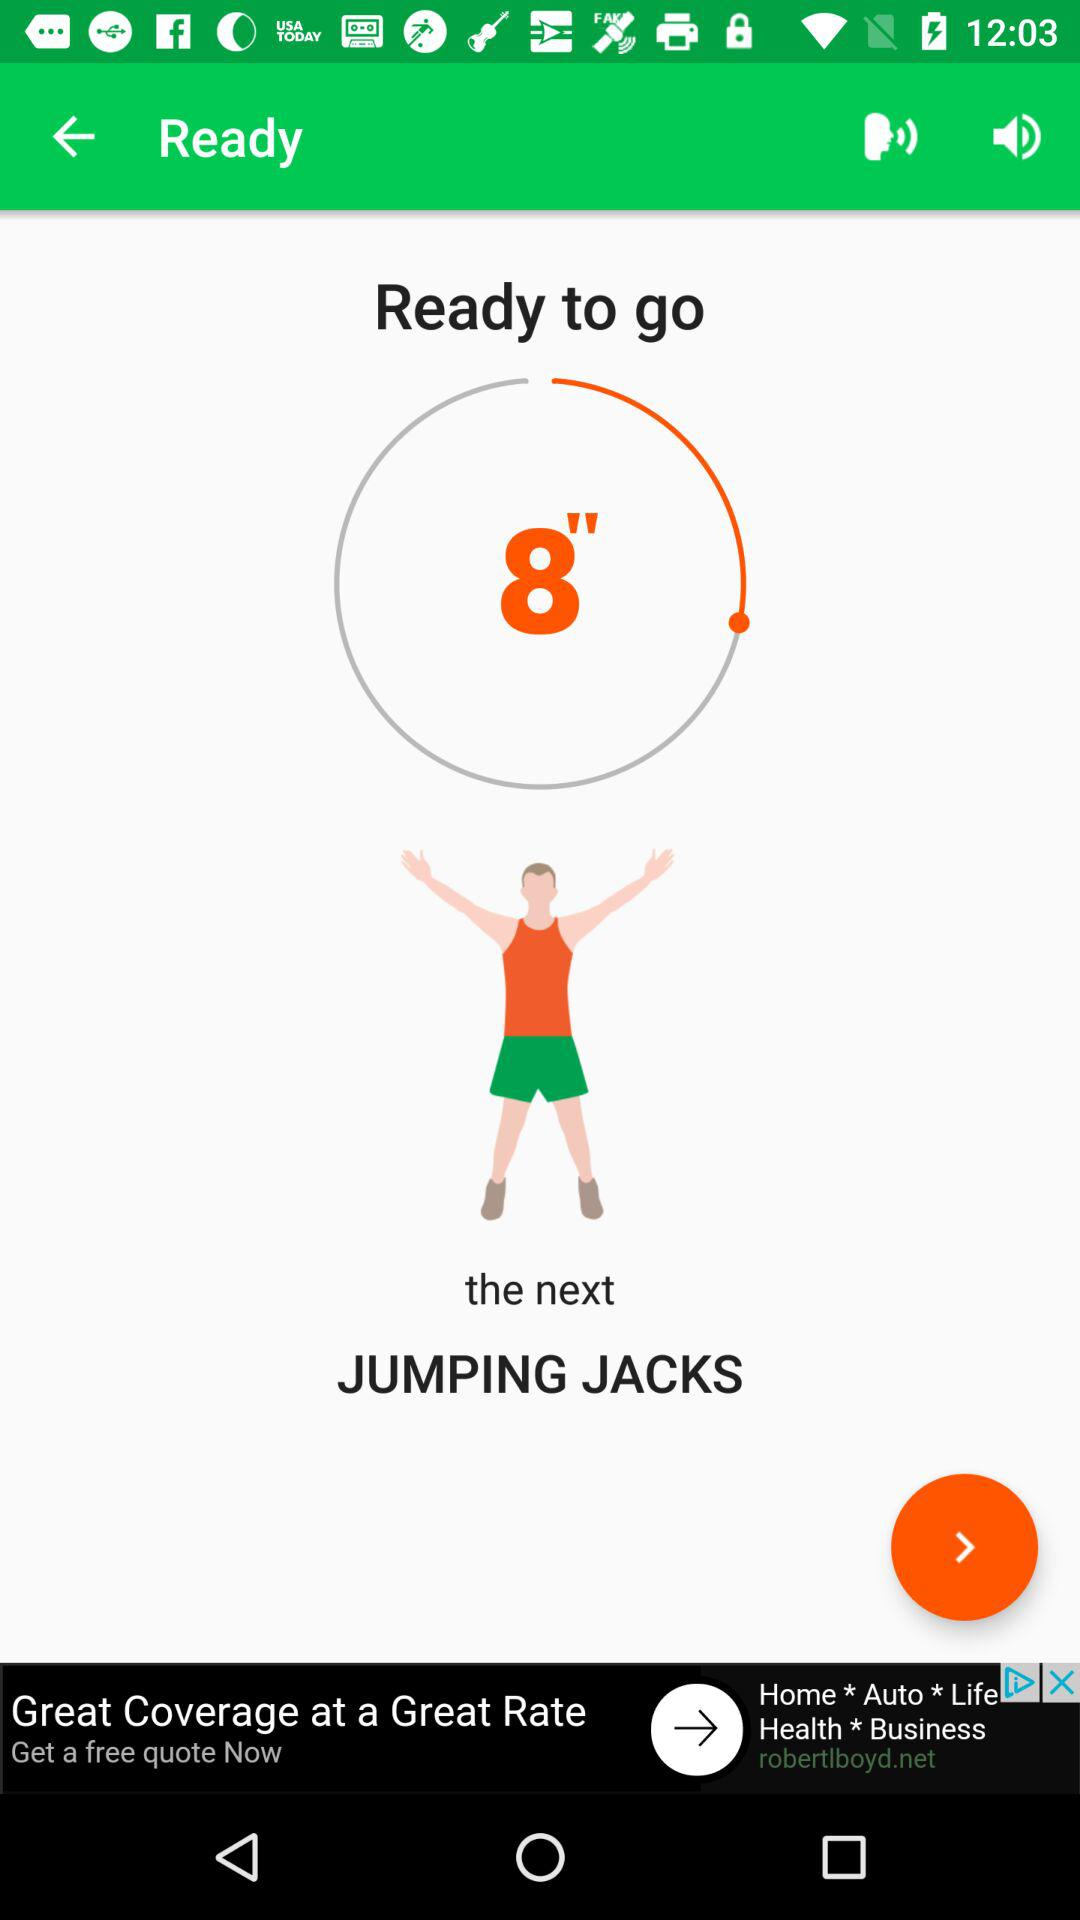How many more jumping jacks do I have to do?
Answer the question using a single word or phrase. 8 